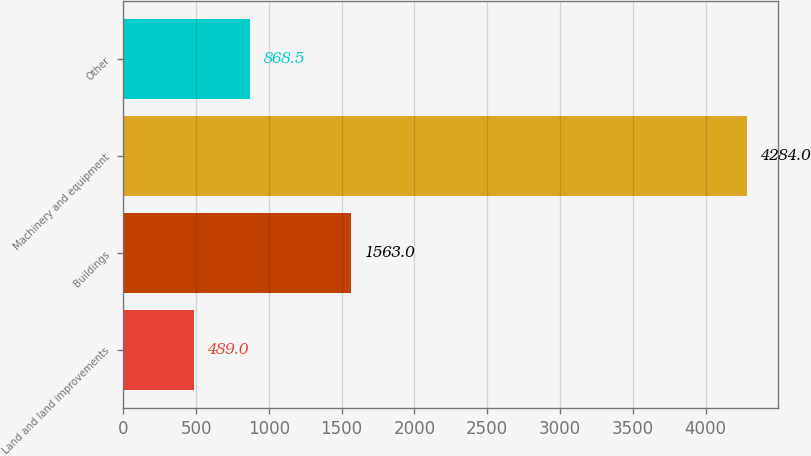Convert chart to OTSL. <chart><loc_0><loc_0><loc_500><loc_500><bar_chart><fcel>Land and land improvements<fcel>Buildings<fcel>Machinery and equipment<fcel>Other<nl><fcel>489<fcel>1563<fcel>4284<fcel>868.5<nl></chart> 